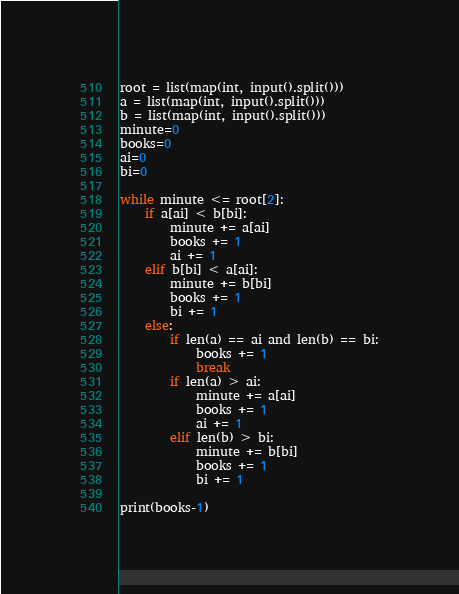Convert code to text. <code><loc_0><loc_0><loc_500><loc_500><_Python_>root = list(map(int, input().split()))
a = list(map(int, input().split()))
b = list(map(int, input().split()))    
minute=0
books=0
ai=0
bi=0

while minute <= root[2]:
    if a[ai] < b[bi]:
        minute += a[ai]
        books += 1
        ai += 1
    elif b[bi] < a[ai]:
        minute += b[bi]
        books += 1
        bi += 1
    else:
        if len(a) == ai and len(b) == bi:
            books += 1
            break
        if len(a) > ai:
            minute += a[ai]
            books += 1
            ai += 1
        elif len(b) > bi:
            minute += b[bi]
            books += 1
            bi += 1

print(books-1)
</code> 